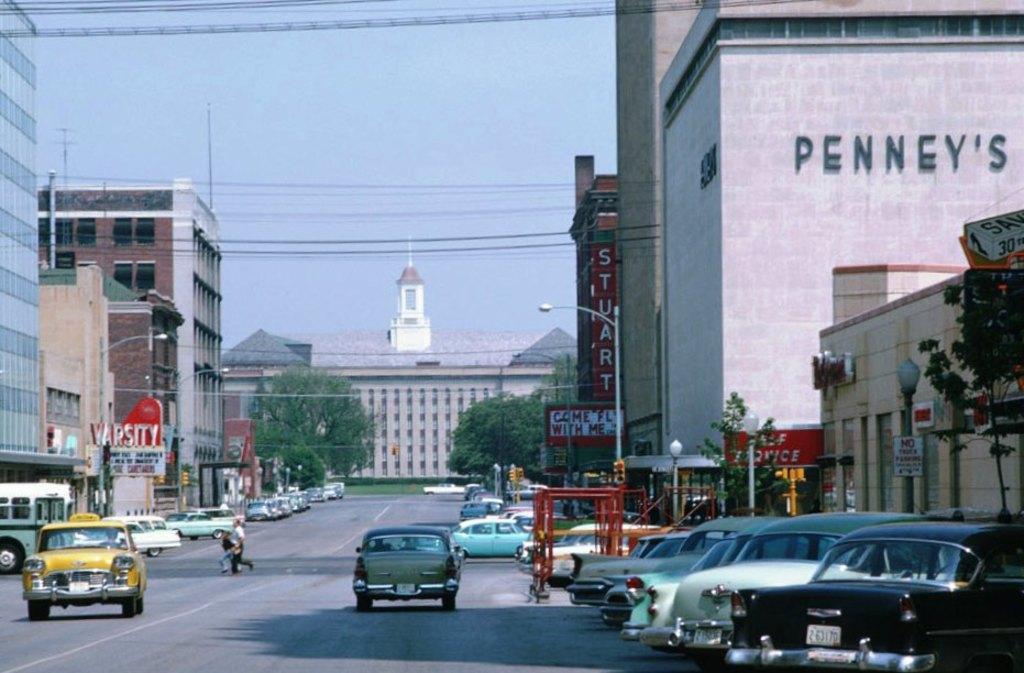<image>
Share a concise interpretation of the image provided. A city street has cars going down it and a large building that says Penney's. 